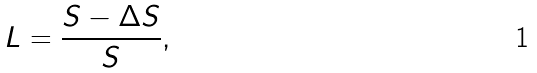Convert formula to latex. <formula><loc_0><loc_0><loc_500><loc_500>L = \frac { S - \Delta S } { S } ,</formula> 